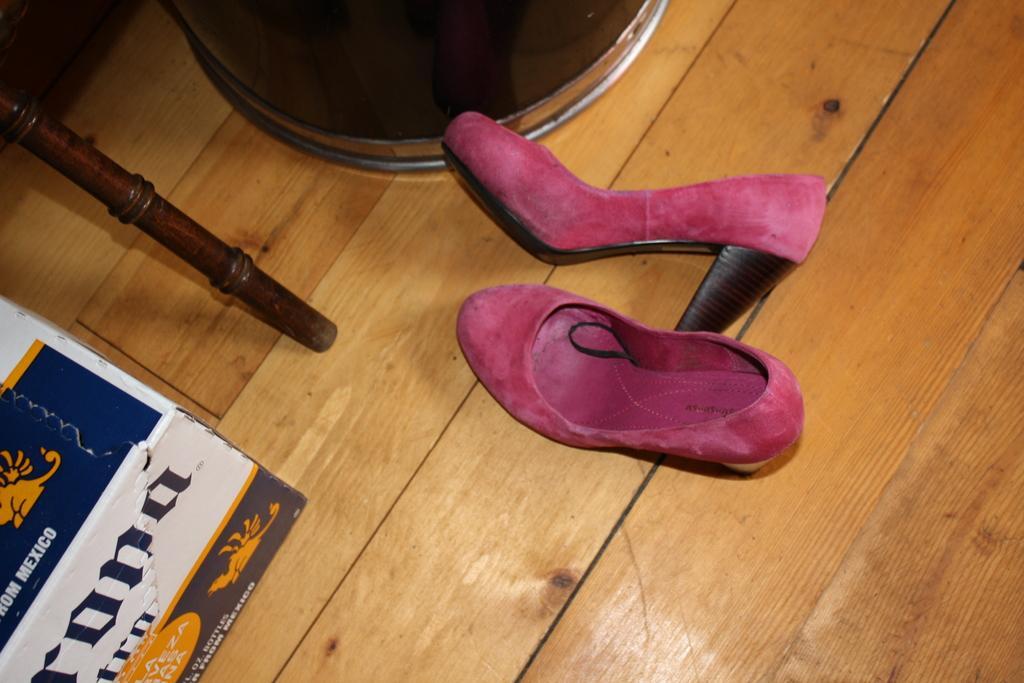Please provide a concise description of this image. In this picture I can see footwear on the wooden floor. 